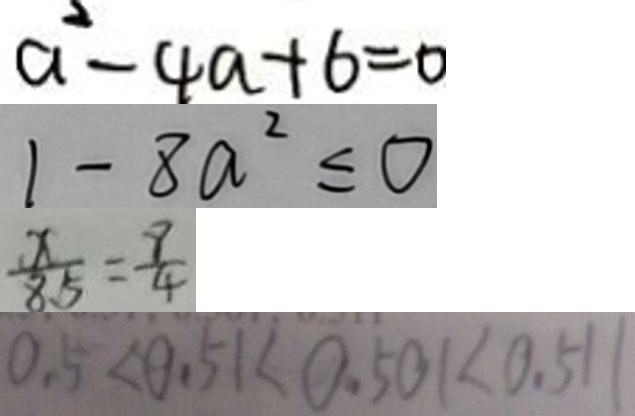Convert formula to latex. <formula><loc_0><loc_0><loc_500><loc_500>a ^ { 2 } - 4 a + 6 = 0 
 1 - 8 a ^ { 2 } \leq 0 
 \frac { x } { 8 5 } = \frac { 9 } { 4 } 
 0 . 5 < 0 . 5 1 < 0 . 5 0 1 < 0 . 5 1 1</formula> 